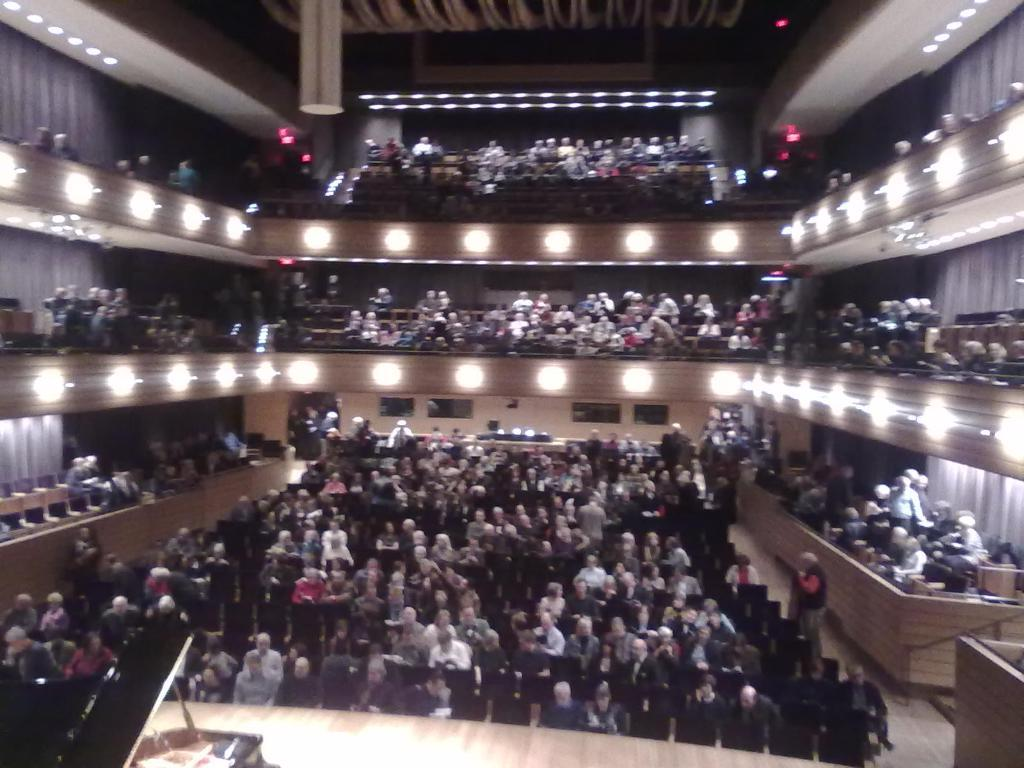How many people are in the image? There are people in the image, but the exact number is not specified. What are some of the people doing in the image? Some people are standing, and some are sitting on chairs. What can be seen in the background of the image? There is a fence and lights visible in the image. What is the main feature on the stage in the image? There is a piano on a stage in the image. What part of the room can be seen above the people in the image? The ceiling is visible in the image. What other objects can be seen in the image besides the people and the piano? There are other objects present in the image, but their specific details are not mentioned. What type of fowl is sitting on the piano in the image? There is no fowl present on the piano in the image. What kind of pet can be seen interacting with the people in the image? There is no pet visible in the image. 